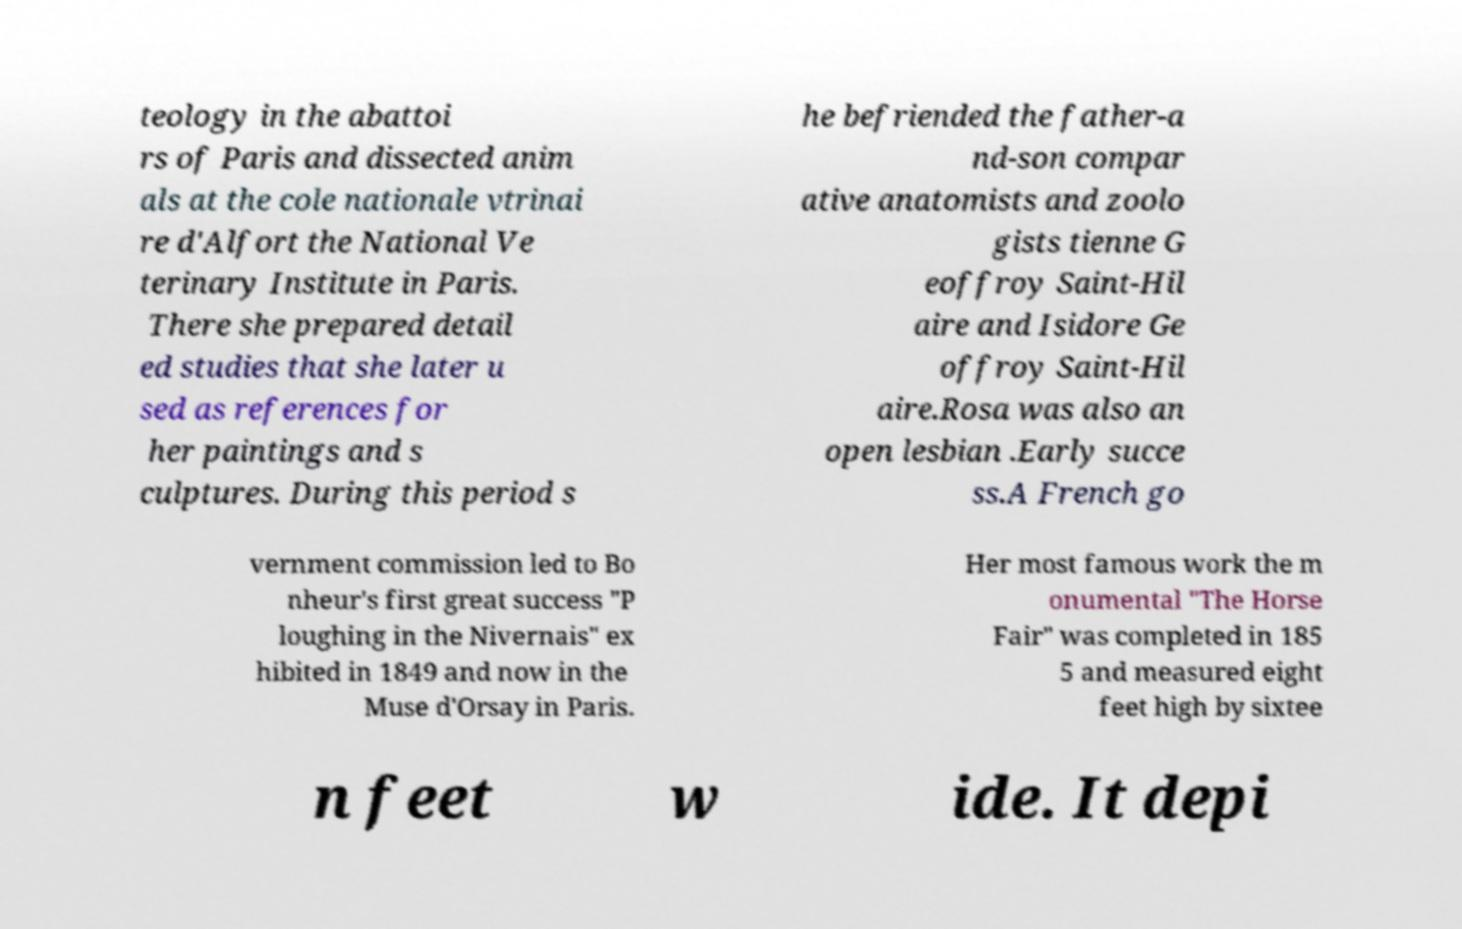For documentation purposes, I need the text within this image transcribed. Could you provide that? teology in the abattoi rs of Paris and dissected anim als at the cole nationale vtrinai re d'Alfort the National Ve terinary Institute in Paris. There she prepared detail ed studies that she later u sed as references for her paintings and s culptures. During this period s he befriended the father-a nd-son compar ative anatomists and zoolo gists tienne G eoffroy Saint-Hil aire and Isidore Ge offroy Saint-Hil aire.Rosa was also an open lesbian .Early succe ss.A French go vernment commission led to Bo nheur's first great success "P loughing in the Nivernais" ex hibited in 1849 and now in the Muse d'Orsay in Paris. Her most famous work the m onumental "The Horse Fair" was completed in 185 5 and measured eight feet high by sixtee n feet w ide. It depi 